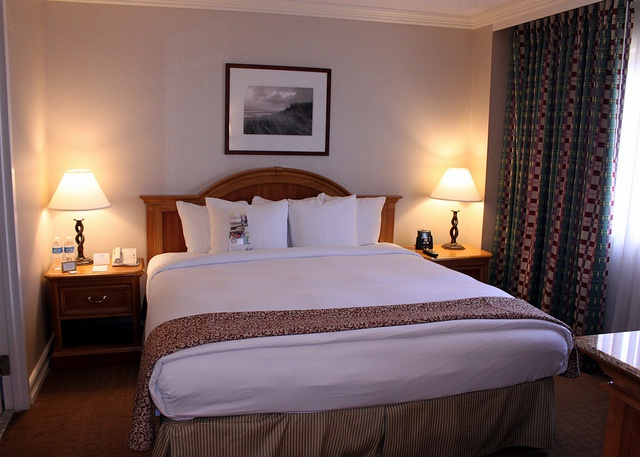Describe the objects in this image and their specific colors. I can see bed in gray, darkgray, black, and maroon tones, bottle in gray, orange, and tan tones, bottle in gray and tan tones, and remote in gray, black, and brown tones in this image. 